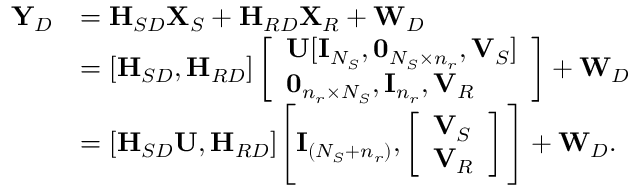Convert formula to latex. <formula><loc_0><loc_0><loc_500><loc_500>\begin{array} { r l } { { \mathbf Y } _ { D } } & { = { H } _ { S D } { \mathbf X } _ { S } + { H } _ { R D } { \mathbf X } _ { R } + { \mathbf W } _ { D } } \\ & { = [ { H } _ { S D } , { H } _ { R D } ] \left [ \begin{array} { l } { { \mathbf U } [ { \mathbf I } _ { N _ { S } } , 0 _ { N _ { S } \times n _ { r } } , { \mathbf V } _ { S } ] } \\ { 0 _ { n _ { r } \times N _ { S } } , { \mathbf I } _ { n _ { r } } , { \mathbf V } _ { R } } \end{array} \right ] + { \mathbf W } _ { D } } \\ & { = [ { H } _ { S D } { \mathbf U } , { H } _ { R D } ] \left [ { \mathbf I } _ { ( N _ { S } + n _ { r } ) } , \left [ \begin{array} { l } { { \mathbf V } _ { S } } \\ { { \mathbf V } _ { R } } \end{array} \right ] \right ] + { \mathbf W } _ { D } . } \end{array}</formula> 